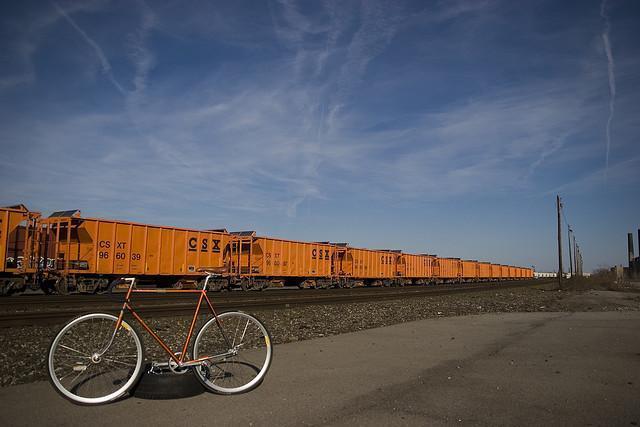How many trees are visible on the right side of the train?
Give a very brief answer. 0. How many bicycles are pictured?
Give a very brief answer. 1. How many people are wearing tie?
Give a very brief answer. 0. 